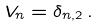Convert formula to latex. <formula><loc_0><loc_0><loc_500><loc_500>V _ { n } = \delta _ { n , 2 } \, .</formula> 